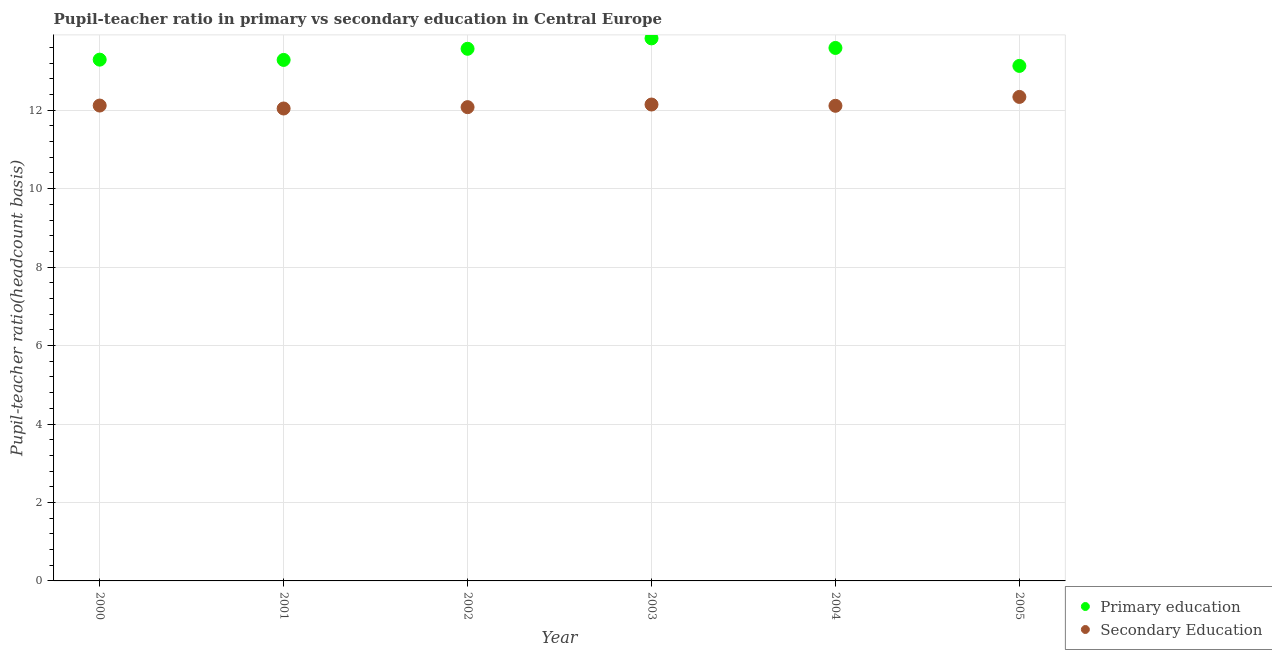Is the number of dotlines equal to the number of legend labels?
Provide a short and direct response. Yes. What is the pupil-teacher ratio in primary education in 2001?
Offer a terse response. 13.28. Across all years, what is the maximum pupil teacher ratio on secondary education?
Make the answer very short. 12.34. Across all years, what is the minimum pupil-teacher ratio in primary education?
Offer a very short reply. 13.13. In which year was the pupil-teacher ratio in primary education maximum?
Your answer should be compact. 2003. What is the total pupil teacher ratio on secondary education in the graph?
Offer a very short reply. 72.84. What is the difference between the pupil-teacher ratio in primary education in 2000 and that in 2003?
Give a very brief answer. -0.54. What is the difference between the pupil-teacher ratio in primary education in 2000 and the pupil teacher ratio on secondary education in 2005?
Keep it short and to the point. 0.95. What is the average pupil teacher ratio on secondary education per year?
Keep it short and to the point. 12.14. In the year 2002, what is the difference between the pupil teacher ratio on secondary education and pupil-teacher ratio in primary education?
Make the answer very short. -1.49. In how many years, is the pupil teacher ratio on secondary education greater than 11.6?
Give a very brief answer. 6. What is the ratio of the pupil-teacher ratio in primary education in 2000 to that in 2002?
Your response must be concise. 0.98. What is the difference between the highest and the second highest pupil-teacher ratio in primary education?
Your answer should be very brief. 0.24. What is the difference between the highest and the lowest pupil teacher ratio on secondary education?
Your answer should be compact. 0.3. Is the sum of the pupil teacher ratio on secondary education in 2002 and 2003 greater than the maximum pupil-teacher ratio in primary education across all years?
Your response must be concise. Yes. Is the pupil-teacher ratio in primary education strictly greater than the pupil teacher ratio on secondary education over the years?
Ensure brevity in your answer.  Yes. Is the pupil-teacher ratio in primary education strictly less than the pupil teacher ratio on secondary education over the years?
Your response must be concise. No. How many dotlines are there?
Keep it short and to the point. 2. How many years are there in the graph?
Provide a short and direct response. 6. What is the difference between two consecutive major ticks on the Y-axis?
Offer a terse response. 2. Does the graph contain any zero values?
Make the answer very short. No. Does the graph contain grids?
Offer a terse response. Yes. How many legend labels are there?
Keep it short and to the point. 2. What is the title of the graph?
Your answer should be very brief. Pupil-teacher ratio in primary vs secondary education in Central Europe. What is the label or title of the Y-axis?
Provide a short and direct response. Pupil-teacher ratio(headcount basis). What is the Pupil-teacher ratio(headcount basis) in Primary education in 2000?
Offer a terse response. 13.29. What is the Pupil-teacher ratio(headcount basis) in Secondary Education in 2000?
Offer a very short reply. 12.12. What is the Pupil-teacher ratio(headcount basis) in Primary education in 2001?
Offer a very short reply. 13.28. What is the Pupil-teacher ratio(headcount basis) of Secondary Education in 2001?
Give a very brief answer. 12.04. What is the Pupil-teacher ratio(headcount basis) in Primary education in 2002?
Offer a terse response. 13.57. What is the Pupil-teacher ratio(headcount basis) of Secondary Education in 2002?
Provide a succinct answer. 12.08. What is the Pupil-teacher ratio(headcount basis) of Primary education in 2003?
Provide a short and direct response. 13.83. What is the Pupil-teacher ratio(headcount basis) in Secondary Education in 2003?
Make the answer very short. 12.14. What is the Pupil-teacher ratio(headcount basis) in Primary education in 2004?
Your answer should be very brief. 13.59. What is the Pupil-teacher ratio(headcount basis) in Secondary Education in 2004?
Your answer should be very brief. 12.11. What is the Pupil-teacher ratio(headcount basis) of Primary education in 2005?
Keep it short and to the point. 13.13. What is the Pupil-teacher ratio(headcount basis) of Secondary Education in 2005?
Provide a succinct answer. 12.34. Across all years, what is the maximum Pupil-teacher ratio(headcount basis) in Primary education?
Ensure brevity in your answer.  13.83. Across all years, what is the maximum Pupil-teacher ratio(headcount basis) of Secondary Education?
Provide a succinct answer. 12.34. Across all years, what is the minimum Pupil-teacher ratio(headcount basis) in Primary education?
Your answer should be compact. 13.13. Across all years, what is the minimum Pupil-teacher ratio(headcount basis) of Secondary Education?
Give a very brief answer. 12.04. What is the total Pupil-teacher ratio(headcount basis) in Primary education in the graph?
Ensure brevity in your answer.  80.68. What is the total Pupil-teacher ratio(headcount basis) of Secondary Education in the graph?
Ensure brevity in your answer.  72.84. What is the difference between the Pupil-teacher ratio(headcount basis) in Primary education in 2000 and that in 2001?
Make the answer very short. 0.01. What is the difference between the Pupil-teacher ratio(headcount basis) of Secondary Education in 2000 and that in 2001?
Offer a very short reply. 0.08. What is the difference between the Pupil-teacher ratio(headcount basis) in Primary education in 2000 and that in 2002?
Provide a succinct answer. -0.28. What is the difference between the Pupil-teacher ratio(headcount basis) of Secondary Education in 2000 and that in 2002?
Your answer should be compact. 0.04. What is the difference between the Pupil-teacher ratio(headcount basis) in Primary education in 2000 and that in 2003?
Your response must be concise. -0.54. What is the difference between the Pupil-teacher ratio(headcount basis) of Secondary Education in 2000 and that in 2003?
Your response must be concise. -0.03. What is the difference between the Pupil-teacher ratio(headcount basis) in Primary education in 2000 and that in 2004?
Make the answer very short. -0.3. What is the difference between the Pupil-teacher ratio(headcount basis) in Secondary Education in 2000 and that in 2004?
Offer a very short reply. 0.01. What is the difference between the Pupil-teacher ratio(headcount basis) in Primary education in 2000 and that in 2005?
Keep it short and to the point. 0.16. What is the difference between the Pupil-teacher ratio(headcount basis) in Secondary Education in 2000 and that in 2005?
Provide a short and direct response. -0.22. What is the difference between the Pupil-teacher ratio(headcount basis) in Primary education in 2001 and that in 2002?
Keep it short and to the point. -0.28. What is the difference between the Pupil-teacher ratio(headcount basis) of Secondary Education in 2001 and that in 2002?
Give a very brief answer. -0.03. What is the difference between the Pupil-teacher ratio(headcount basis) in Primary education in 2001 and that in 2003?
Offer a terse response. -0.55. What is the difference between the Pupil-teacher ratio(headcount basis) in Secondary Education in 2001 and that in 2003?
Offer a terse response. -0.1. What is the difference between the Pupil-teacher ratio(headcount basis) of Primary education in 2001 and that in 2004?
Ensure brevity in your answer.  -0.31. What is the difference between the Pupil-teacher ratio(headcount basis) of Secondary Education in 2001 and that in 2004?
Your answer should be very brief. -0.07. What is the difference between the Pupil-teacher ratio(headcount basis) in Primary education in 2001 and that in 2005?
Offer a terse response. 0.15. What is the difference between the Pupil-teacher ratio(headcount basis) in Secondary Education in 2001 and that in 2005?
Your answer should be compact. -0.3. What is the difference between the Pupil-teacher ratio(headcount basis) of Primary education in 2002 and that in 2003?
Make the answer very short. -0.27. What is the difference between the Pupil-teacher ratio(headcount basis) in Secondary Education in 2002 and that in 2003?
Ensure brevity in your answer.  -0.07. What is the difference between the Pupil-teacher ratio(headcount basis) of Primary education in 2002 and that in 2004?
Offer a terse response. -0.02. What is the difference between the Pupil-teacher ratio(headcount basis) in Secondary Education in 2002 and that in 2004?
Keep it short and to the point. -0.03. What is the difference between the Pupil-teacher ratio(headcount basis) of Primary education in 2002 and that in 2005?
Give a very brief answer. 0.44. What is the difference between the Pupil-teacher ratio(headcount basis) of Secondary Education in 2002 and that in 2005?
Provide a succinct answer. -0.26. What is the difference between the Pupil-teacher ratio(headcount basis) in Primary education in 2003 and that in 2004?
Provide a short and direct response. 0.24. What is the difference between the Pupil-teacher ratio(headcount basis) of Secondary Education in 2003 and that in 2004?
Provide a short and direct response. 0.03. What is the difference between the Pupil-teacher ratio(headcount basis) of Primary education in 2003 and that in 2005?
Ensure brevity in your answer.  0.7. What is the difference between the Pupil-teacher ratio(headcount basis) in Secondary Education in 2003 and that in 2005?
Your answer should be very brief. -0.19. What is the difference between the Pupil-teacher ratio(headcount basis) of Primary education in 2004 and that in 2005?
Your response must be concise. 0.46. What is the difference between the Pupil-teacher ratio(headcount basis) of Secondary Education in 2004 and that in 2005?
Your answer should be very brief. -0.23. What is the difference between the Pupil-teacher ratio(headcount basis) in Primary education in 2000 and the Pupil-teacher ratio(headcount basis) in Secondary Education in 2001?
Offer a very short reply. 1.25. What is the difference between the Pupil-teacher ratio(headcount basis) of Primary education in 2000 and the Pupil-teacher ratio(headcount basis) of Secondary Education in 2002?
Keep it short and to the point. 1.21. What is the difference between the Pupil-teacher ratio(headcount basis) of Primary education in 2000 and the Pupil-teacher ratio(headcount basis) of Secondary Education in 2003?
Your response must be concise. 1.14. What is the difference between the Pupil-teacher ratio(headcount basis) of Primary education in 2000 and the Pupil-teacher ratio(headcount basis) of Secondary Education in 2004?
Your answer should be compact. 1.18. What is the difference between the Pupil-teacher ratio(headcount basis) of Primary education in 2000 and the Pupil-teacher ratio(headcount basis) of Secondary Education in 2005?
Your answer should be very brief. 0.95. What is the difference between the Pupil-teacher ratio(headcount basis) of Primary education in 2001 and the Pupil-teacher ratio(headcount basis) of Secondary Education in 2002?
Ensure brevity in your answer.  1.2. What is the difference between the Pupil-teacher ratio(headcount basis) in Primary education in 2001 and the Pupil-teacher ratio(headcount basis) in Secondary Education in 2003?
Provide a short and direct response. 1.14. What is the difference between the Pupil-teacher ratio(headcount basis) in Primary education in 2001 and the Pupil-teacher ratio(headcount basis) in Secondary Education in 2004?
Your answer should be compact. 1.17. What is the difference between the Pupil-teacher ratio(headcount basis) of Primary education in 2001 and the Pupil-teacher ratio(headcount basis) of Secondary Education in 2005?
Provide a succinct answer. 0.94. What is the difference between the Pupil-teacher ratio(headcount basis) of Primary education in 2002 and the Pupil-teacher ratio(headcount basis) of Secondary Education in 2003?
Offer a terse response. 1.42. What is the difference between the Pupil-teacher ratio(headcount basis) in Primary education in 2002 and the Pupil-teacher ratio(headcount basis) in Secondary Education in 2004?
Provide a succinct answer. 1.45. What is the difference between the Pupil-teacher ratio(headcount basis) in Primary education in 2002 and the Pupil-teacher ratio(headcount basis) in Secondary Education in 2005?
Give a very brief answer. 1.23. What is the difference between the Pupil-teacher ratio(headcount basis) in Primary education in 2003 and the Pupil-teacher ratio(headcount basis) in Secondary Education in 2004?
Your answer should be very brief. 1.72. What is the difference between the Pupil-teacher ratio(headcount basis) of Primary education in 2003 and the Pupil-teacher ratio(headcount basis) of Secondary Education in 2005?
Offer a very short reply. 1.49. What is the difference between the Pupil-teacher ratio(headcount basis) of Primary education in 2004 and the Pupil-teacher ratio(headcount basis) of Secondary Education in 2005?
Your response must be concise. 1.25. What is the average Pupil-teacher ratio(headcount basis) in Primary education per year?
Offer a terse response. 13.45. What is the average Pupil-teacher ratio(headcount basis) in Secondary Education per year?
Your answer should be very brief. 12.14. In the year 2000, what is the difference between the Pupil-teacher ratio(headcount basis) in Primary education and Pupil-teacher ratio(headcount basis) in Secondary Education?
Provide a short and direct response. 1.17. In the year 2001, what is the difference between the Pupil-teacher ratio(headcount basis) in Primary education and Pupil-teacher ratio(headcount basis) in Secondary Education?
Provide a short and direct response. 1.24. In the year 2002, what is the difference between the Pupil-teacher ratio(headcount basis) of Primary education and Pupil-teacher ratio(headcount basis) of Secondary Education?
Make the answer very short. 1.49. In the year 2003, what is the difference between the Pupil-teacher ratio(headcount basis) of Primary education and Pupil-teacher ratio(headcount basis) of Secondary Education?
Provide a short and direct response. 1.69. In the year 2004, what is the difference between the Pupil-teacher ratio(headcount basis) of Primary education and Pupil-teacher ratio(headcount basis) of Secondary Education?
Provide a succinct answer. 1.47. In the year 2005, what is the difference between the Pupil-teacher ratio(headcount basis) in Primary education and Pupil-teacher ratio(headcount basis) in Secondary Education?
Your response must be concise. 0.79. What is the ratio of the Pupil-teacher ratio(headcount basis) in Primary education in 2000 to that in 2001?
Make the answer very short. 1. What is the ratio of the Pupil-teacher ratio(headcount basis) in Secondary Education in 2000 to that in 2001?
Ensure brevity in your answer.  1.01. What is the ratio of the Pupil-teacher ratio(headcount basis) in Primary education in 2000 to that in 2002?
Provide a short and direct response. 0.98. What is the ratio of the Pupil-teacher ratio(headcount basis) in Secondary Education in 2000 to that in 2002?
Keep it short and to the point. 1. What is the ratio of the Pupil-teacher ratio(headcount basis) of Primary education in 2000 to that in 2003?
Keep it short and to the point. 0.96. What is the ratio of the Pupil-teacher ratio(headcount basis) in Primary education in 2000 to that in 2004?
Give a very brief answer. 0.98. What is the ratio of the Pupil-teacher ratio(headcount basis) in Secondary Education in 2000 to that in 2004?
Your response must be concise. 1. What is the ratio of the Pupil-teacher ratio(headcount basis) of Primary education in 2000 to that in 2005?
Provide a succinct answer. 1.01. What is the ratio of the Pupil-teacher ratio(headcount basis) in Secondary Education in 2000 to that in 2005?
Ensure brevity in your answer.  0.98. What is the ratio of the Pupil-teacher ratio(headcount basis) in Primary education in 2001 to that in 2002?
Offer a terse response. 0.98. What is the ratio of the Pupil-teacher ratio(headcount basis) in Secondary Education in 2001 to that in 2002?
Make the answer very short. 1. What is the ratio of the Pupil-teacher ratio(headcount basis) in Primary education in 2001 to that in 2003?
Ensure brevity in your answer.  0.96. What is the ratio of the Pupil-teacher ratio(headcount basis) of Secondary Education in 2001 to that in 2003?
Your answer should be very brief. 0.99. What is the ratio of the Pupil-teacher ratio(headcount basis) of Primary education in 2001 to that in 2004?
Provide a short and direct response. 0.98. What is the ratio of the Pupil-teacher ratio(headcount basis) of Primary education in 2001 to that in 2005?
Provide a succinct answer. 1.01. What is the ratio of the Pupil-teacher ratio(headcount basis) of Secondary Education in 2001 to that in 2005?
Make the answer very short. 0.98. What is the ratio of the Pupil-teacher ratio(headcount basis) of Primary education in 2002 to that in 2003?
Your response must be concise. 0.98. What is the ratio of the Pupil-teacher ratio(headcount basis) of Primary education in 2002 to that in 2004?
Provide a succinct answer. 1. What is the ratio of the Pupil-teacher ratio(headcount basis) in Secondary Education in 2002 to that in 2004?
Keep it short and to the point. 1. What is the ratio of the Pupil-teacher ratio(headcount basis) in Secondary Education in 2002 to that in 2005?
Offer a very short reply. 0.98. What is the ratio of the Pupil-teacher ratio(headcount basis) of Primary education in 2003 to that in 2004?
Provide a succinct answer. 1.02. What is the ratio of the Pupil-teacher ratio(headcount basis) in Secondary Education in 2003 to that in 2004?
Make the answer very short. 1. What is the ratio of the Pupil-teacher ratio(headcount basis) of Primary education in 2003 to that in 2005?
Give a very brief answer. 1.05. What is the ratio of the Pupil-teacher ratio(headcount basis) of Secondary Education in 2003 to that in 2005?
Offer a very short reply. 0.98. What is the ratio of the Pupil-teacher ratio(headcount basis) of Primary education in 2004 to that in 2005?
Provide a short and direct response. 1.03. What is the ratio of the Pupil-teacher ratio(headcount basis) of Secondary Education in 2004 to that in 2005?
Offer a terse response. 0.98. What is the difference between the highest and the second highest Pupil-teacher ratio(headcount basis) of Primary education?
Keep it short and to the point. 0.24. What is the difference between the highest and the second highest Pupil-teacher ratio(headcount basis) of Secondary Education?
Provide a succinct answer. 0.19. What is the difference between the highest and the lowest Pupil-teacher ratio(headcount basis) of Primary education?
Offer a terse response. 0.7. What is the difference between the highest and the lowest Pupil-teacher ratio(headcount basis) in Secondary Education?
Provide a succinct answer. 0.3. 